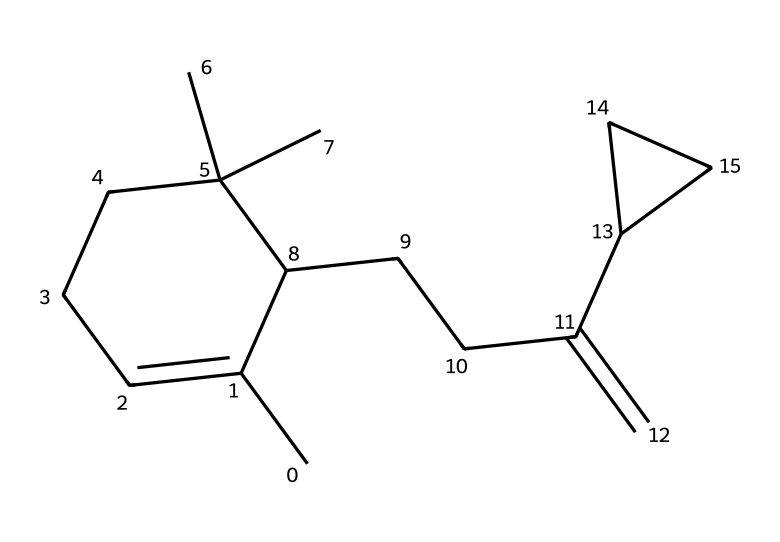What is the molecular formula of caryophyllene? To determine the molecular formula, we count the number of carbon (C) and hydrogen (H) atoms in the structure. By analyzing the SMILES representation, we find there are 15 carbon atoms and 24 hydrogen atoms. Thus, the molecular formula is C15H24.
Answer: C15H24 How many rings are present in the structure of caryophyllene? Upon examining the structure represented by the SMILES notation, there are two distinct ring structures noted in the chemical. Therefore, the total number of rings is 2.
Answer: 2 What type of chemical compound is caryophyllene classified as? Caryophyllene is primarily known as a terpene. By identifying the structure in the SMILES representation, it can be categorized based on the presence of isoprene units and its natural occurrence in plants.
Answer: terpene What is the number of double bonds in caryophyllene? To determine the number of double bonds, we look at the connectivity within the SMILES notation and count the '=' symbols which indicate double bonds. In the structure of caryophyllene, there is one double bond present.
Answer: 1 Which element forms the majority in the molecular structure of caryophyllene? By analyzing the counted atoms from the molecular formula (C15H24), we see that carbon is the most abundant element, as there are 15 carbon atoms compared to 24 hydrogen atoms.
Answer: carbon How does the presence of caryophyllene in snacks affect their flavor? Caryophyllene contributes a spicy, peppery flavor due to its chemical structure and sensory attributes derived from its ring structure. This unique combination of structure imparting flavor is characteristic of many natural terpenes.
Answer: spicy flavor 